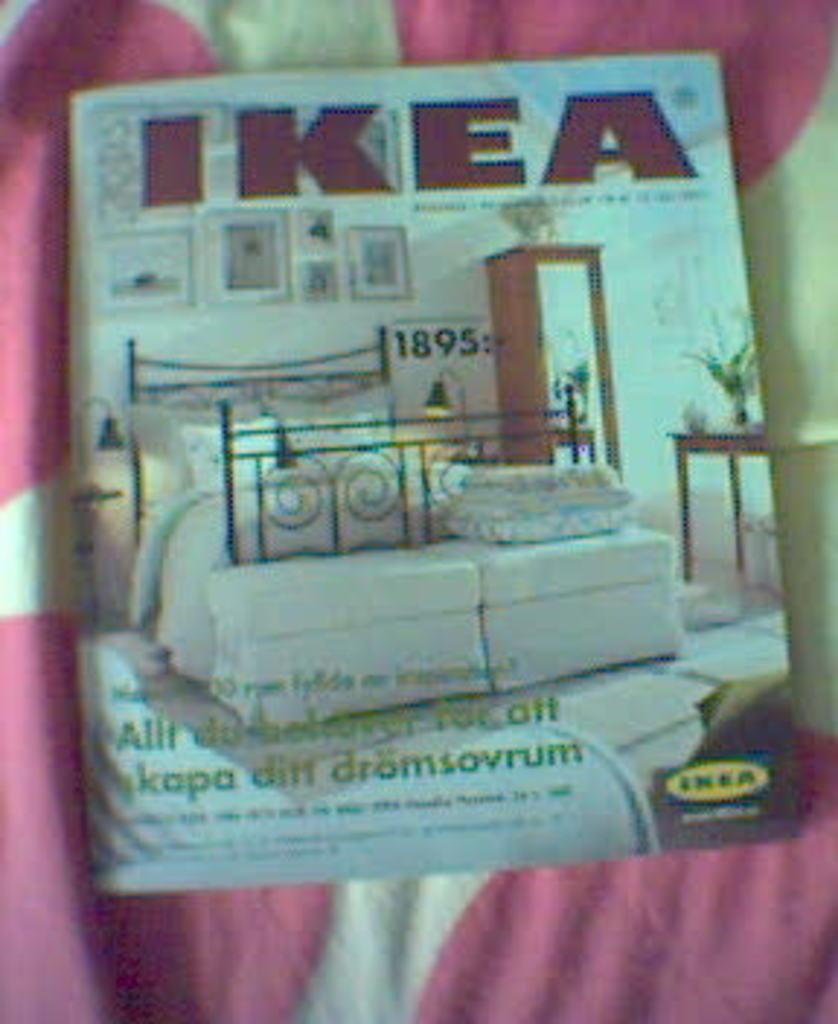What object is present in the image that is related to reading or learning? There is a book in the image. Can you describe the cover page of the book? The cover page of the book has a picture of a room and text. What is the purpose of the cloth under the book? The cloth under the book might be used to protect the surface it is placed on or to prevent the book from slipping. What type of collar can be seen on the family members in the image? There are no family members or collars present in the image; it only features a book with a cover page and a cloth underneath it. 